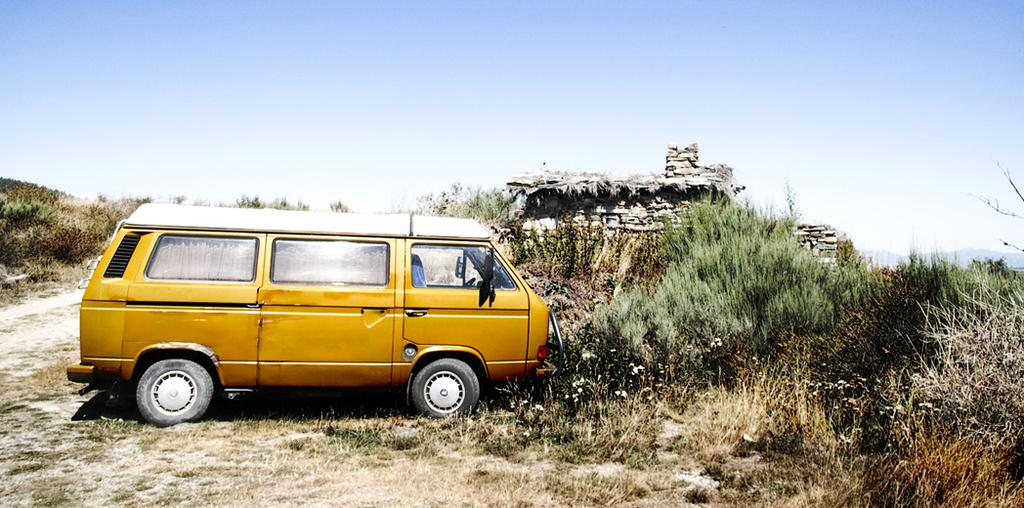What type of vehicle is in the image? There is a van in the image. What else can be seen in the image besides the van? Plants are visible in the image. What is visible in the background of the image? The sky is visible in the background of the image. What type of blade is being used topped up with light in the image? There is no blade or light present in the image; it features a van and plants with the sky visible in the background. 